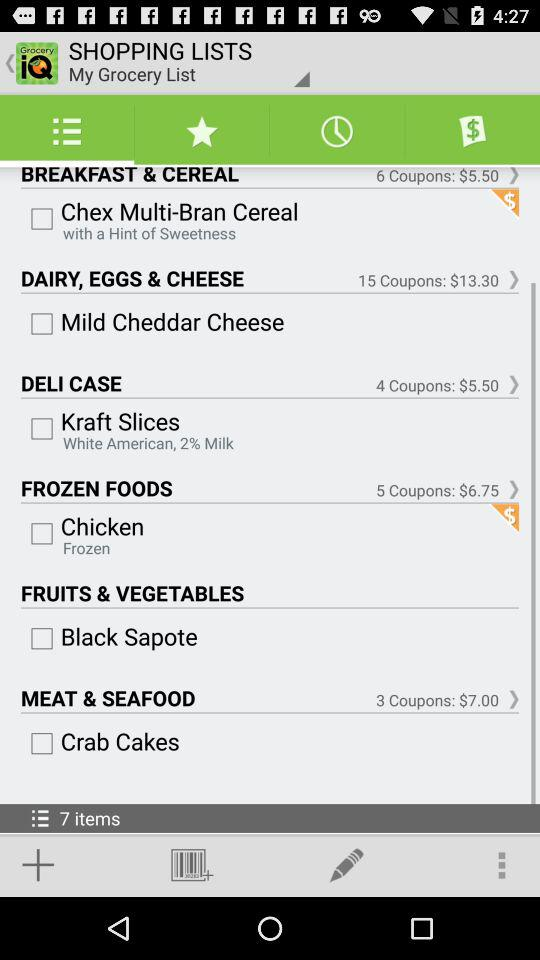On frozen foods, how many coupons are there? There are 5 coupons. 